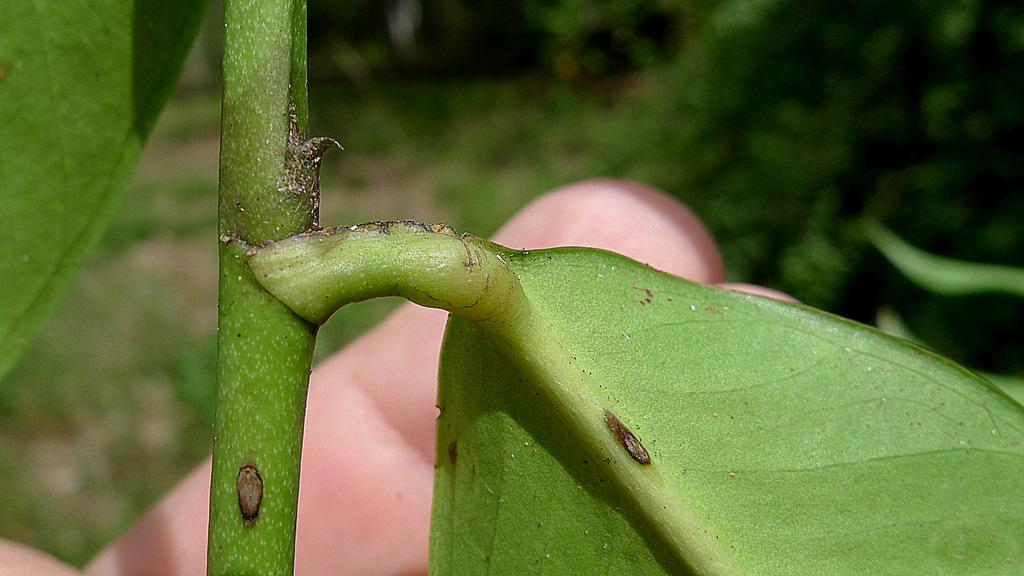What is the main subject of the image? The main subject of the image is a leaf. What color is the leaf in the image? The leaf is green. What else is green in the image? The steam in the image is also green. How would you describe the background of the image? The background of the image is blurry. How many laborers can be seen working in the image? There are no laborers present in the image; it features a leaf and green steam with a blurry background. 